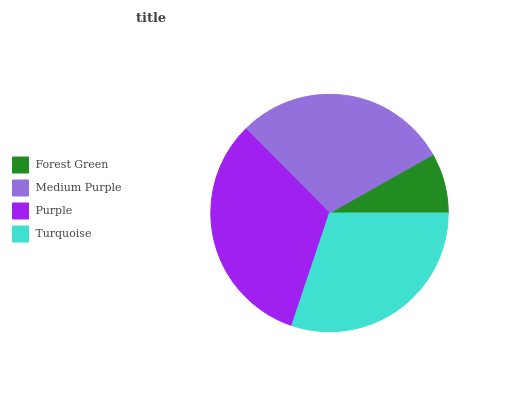Is Forest Green the minimum?
Answer yes or no. Yes. Is Purple the maximum?
Answer yes or no. Yes. Is Medium Purple the minimum?
Answer yes or no. No. Is Medium Purple the maximum?
Answer yes or no. No. Is Medium Purple greater than Forest Green?
Answer yes or no. Yes. Is Forest Green less than Medium Purple?
Answer yes or no. Yes. Is Forest Green greater than Medium Purple?
Answer yes or no. No. Is Medium Purple less than Forest Green?
Answer yes or no. No. Is Turquoise the high median?
Answer yes or no. Yes. Is Medium Purple the low median?
Answer yes or no. Yes. Is Purple the high median?
Answer yes or no. No. Is Forest Green the low median?
Answer yes or no. No. 